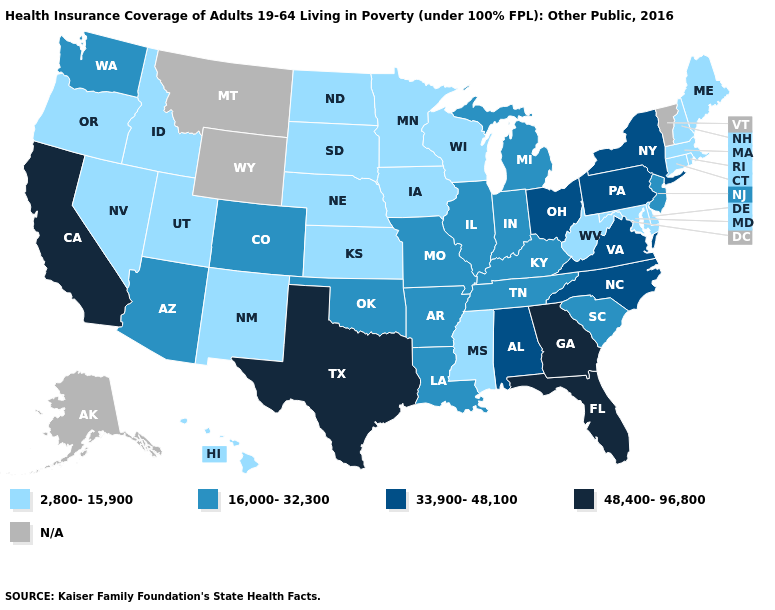What is the value of Arkansas?
Answer briefly. 16,000-32,300. Among the states that border Iowa , which have the highest value?
Give a very brief answer. Illinois, Missouri. What is the value of New Hampshire?
Write a very short answer. 2,800-15,900. Name the states that have a value in the range N/A?
Answer briefly. Alaska, Montana, Vermont, Wyoming. Name the states that have a value in the range 33,900-48,100?
Give a very brief answer. Alabama, New York, North Carolina, Ohio, Pennsylvania, Virginia. Name the states that have a value in the range N/A?
Keep it brief. Alaska, Montana, Vermont, Wyoming. Is the legend a continuous bar?
Keep it brief. No. Name the states that have a value in the range 2,800-15,900?
Give a very brief answer. Connecticut, Delaware, Hawaii, Idaho, Iowa, Kansas, Maine, Maryland, Massachusetts, Minnesota, Mississippi, Nebraska, Nevada, New Hampshire, New Mexico, North Dakota, Oregon, Rhode Island, South Dakota, Utah, West Virginia, Wisconsin. Which states hav the highest value in the MidWest?
Quick response, please. Ohio. What is the value of New Mexico?
Write a very short answer. 2,800-15,900. What is the value of Georgia?
Quick response, please. 48,400-96,800. What is the value of Florida?
Give a very brief answer. 48,400-96,800. What is the lowest value in the USA?
Be succinct. 2,800-15,900. Which states hav the highest value in the South?
Quick response, please. Florida, Georgia, Texas. 